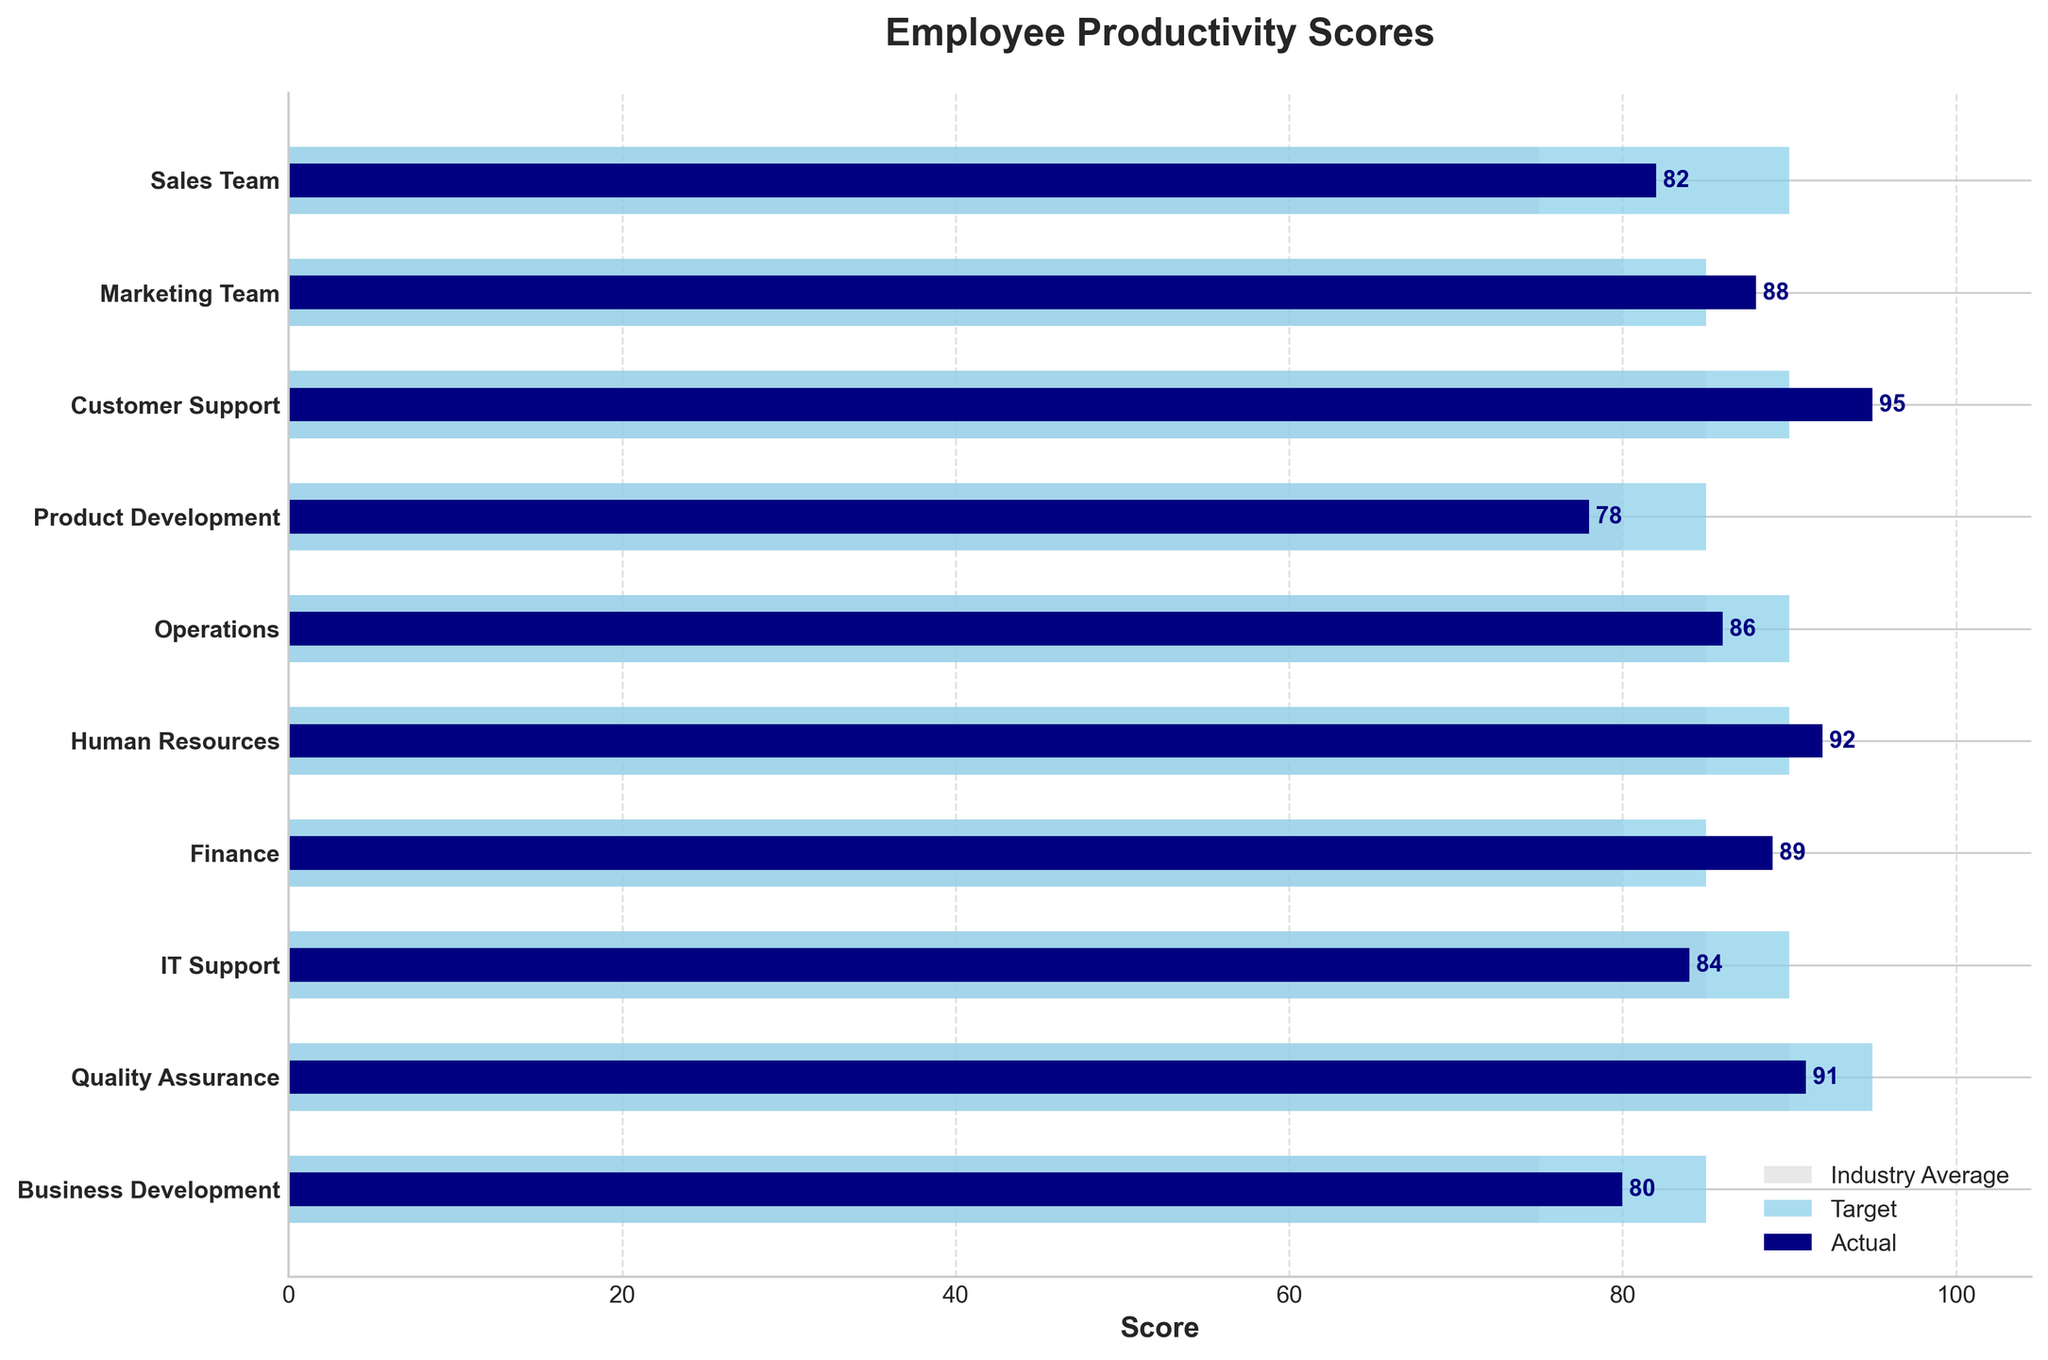How many employees have an actual productivity score higher than the industry average? To find this, we need to compare the Actual scores with the Industry Average scores for each employee. If the Actual score is greater than the Industry Average, we count it. This applies to Sales Team, Marketing Team, Customer Support, Human Resources, Finance, IT Support, and Quality Assurance. Hence, 7 employees have an actual score higher than the industry average.
Answer: 7 What's the highest actual productivity score, and which employee does it belong to? The highest actual productivity score in the chart is 95, which belongs to Customer Support.
Answer: 95 (Customer Support) Which team meets or exceeds their target productivity score? By comparing the Actual scores to the Target scores, we see that Customer Support, Marketing Team, Human Resources, and Finance have Actual scores that meet or surpass their Target scores.
Answer: Customer Support, Marketing Team, Human Resources, Finance How much higher is the actual productivity score of the Customer Support team compared to the Operations team? The Actual score for Customer Support is 95, and for Operations, it is 86. The difference can be calculated as 95 - 86 = 9. Thus, the Customer Support team's productivity score is 9 points higher than the Operations team's.
Answer: 9 Which employee has the smallest difference between their actual productivity score and the industry average? To find the smallest difference, we need to look at the absolute values of the differences between Actual and Industry Average scores for each employee. The smallest difference is for the Product Development team, with a difference of 78 - 80 = -2.
Answer: Product Development Which team's actual productivity score most significantly exceeds the industry average score? The team with the greatest difference would be identified by the highest positive difference between Actual and Industry Average scores. This is Customer Support with a difference of 95 - 85 = 10.
Answer: Customer Support Which team falls the farthest short of their target productivity score? To find this, we subtract the Actual score from the Target score for each team. The team with the most significant shortfall is the Quality Assurance team, with a difference of 95 - 91 = 4.
Answer: Quality Assurance What's the average target productivity score for all the teams? To find the average Target score, sum up all Target scores and divide by the number of teams: (90 + 85 + 90 + 85 + 90 + 90 + 85 + 90 + 95 + 85) / 10 = 88.5.
Answer: 88.5 For which team is the actual productivity score exactly equal to the industry average? We compare the Actual scores with the Industry Average scores. For IT Support, both scores are 84, meaning their actual productivity score matches the industry average.
Answer: IT Support 